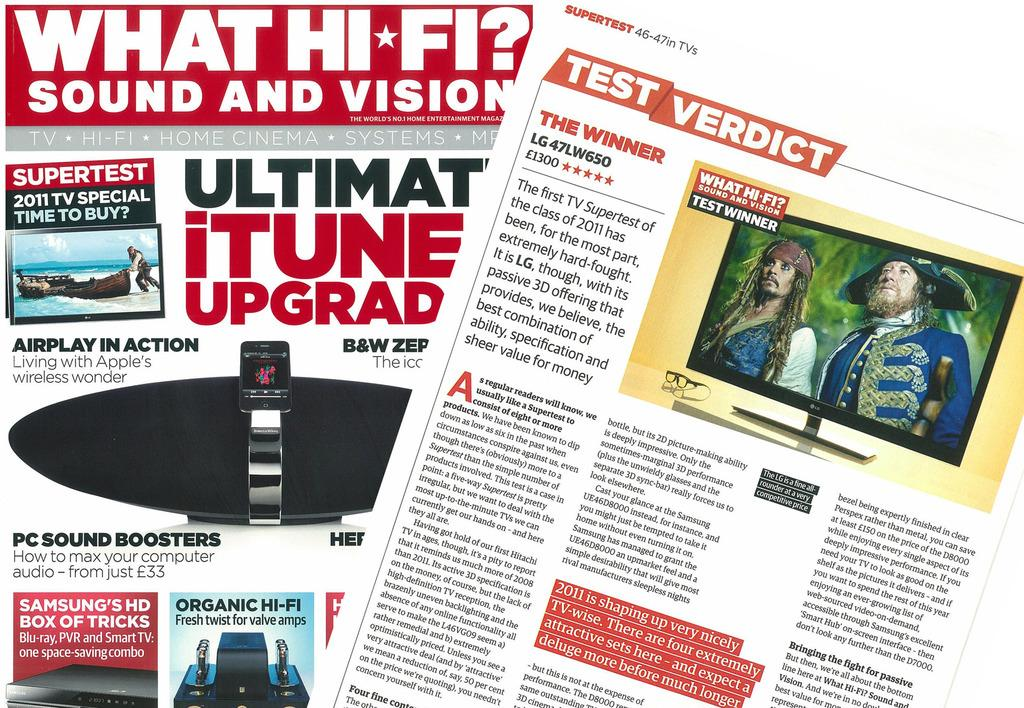What type of printed materials can be seen in the image? There are pamphlets in the image. What is written on the pamphlets? There is writing on the pamphlets. What electronic devices are present in the image? There are screens in the image. What else can be seen in the image besides the pamphlets and screens? There are objects in the image. What color is the background of the image? The background of the image is white. How many beggars can be seen in the image? There are no beggars present in the image. What type of land is visible in the image? There is no land visible in the image; it is focused on printed materials and electronic devices. 